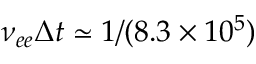<formula> <loc_0><loc_0><loc_500><loc_500>\nu _ { e e } \Delta t \simeq 1 / ( 8 . 3 \times 1 0 ^ { 5 } )</formula> 